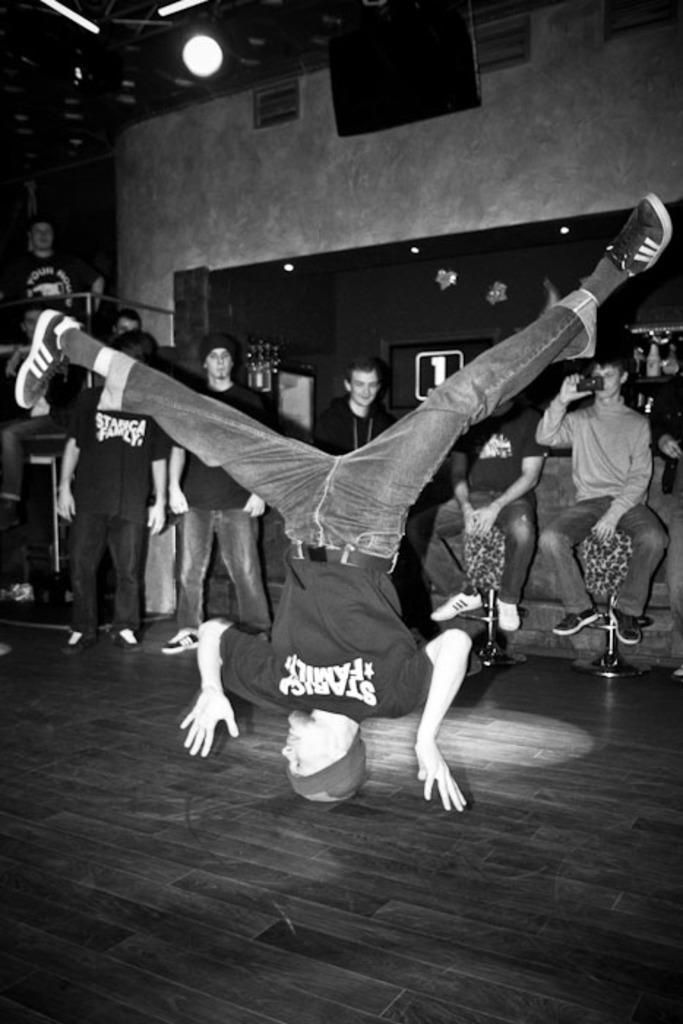Can you describe this image briefly? In the image we can see there are many people standing and some of them are sitting. This person is upside down, this is a wooden floor, stool and light. 